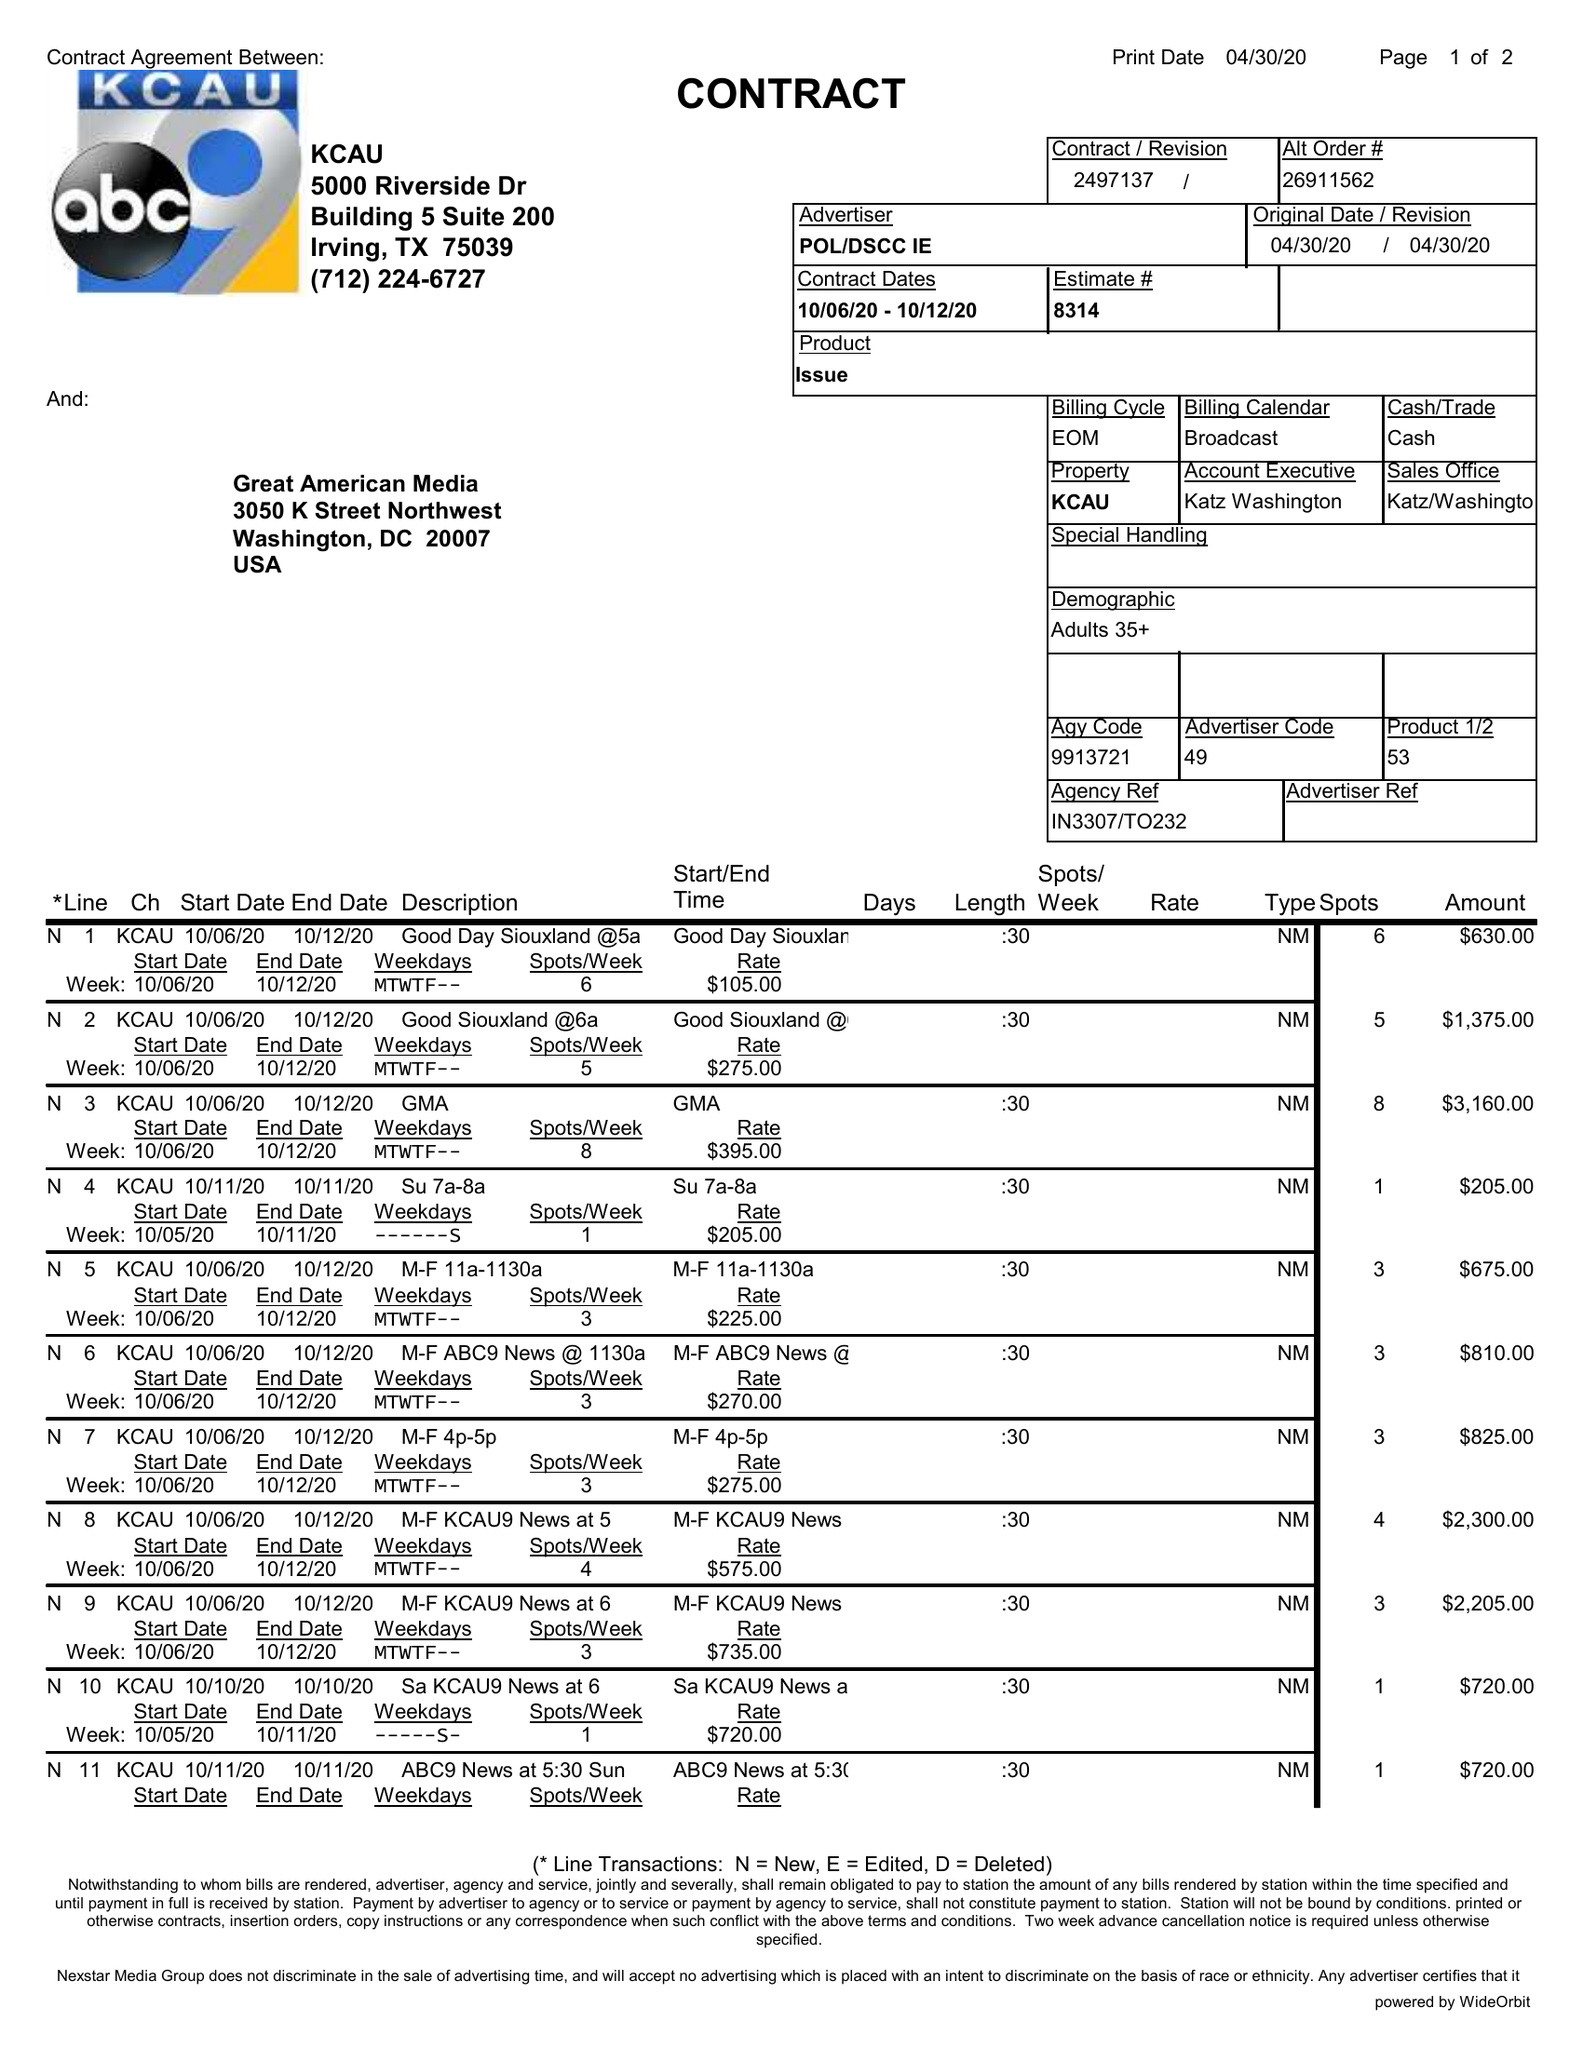What is the value for the flight_to?
Answer the question using a single word or phrase. 10/12/20 